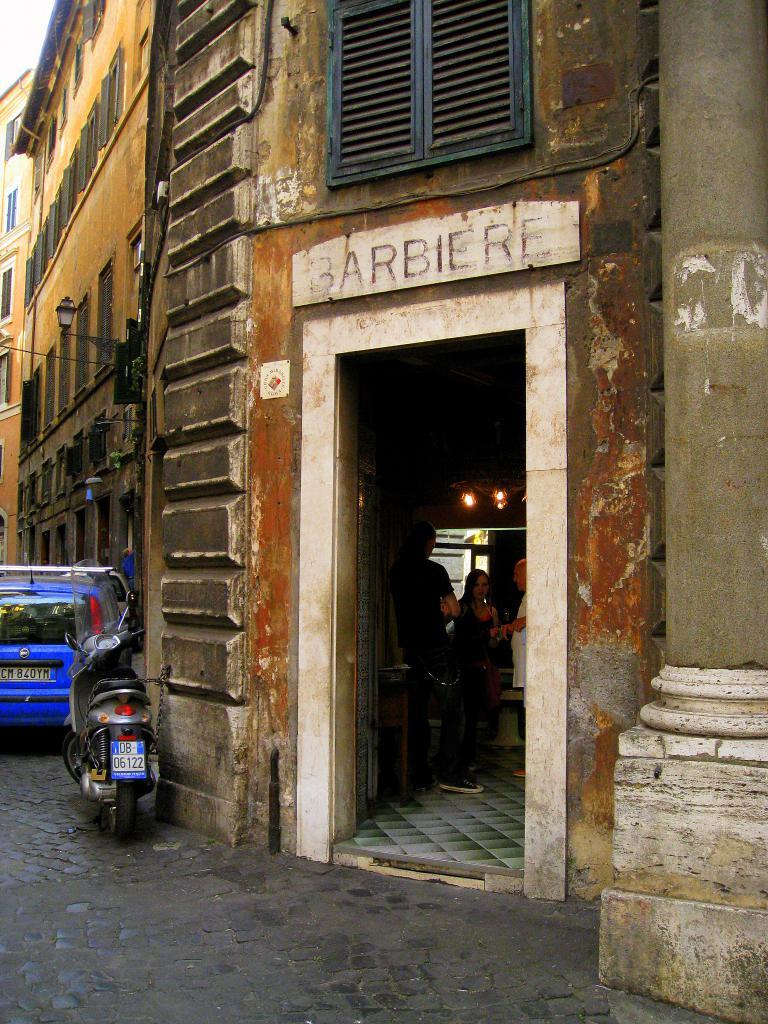What can be found inside the building in the image? There are people in the building. What is located on the ground outside the building? There are vehicles on the ground. What feature can be seen on the building's exterior? There are windows in the building. What color is the orange hanging from the pail? There is no orange or pail present in the image. How does the throat of the person in the building look like? The image does not provide any information about the appearance of the people's throats. 